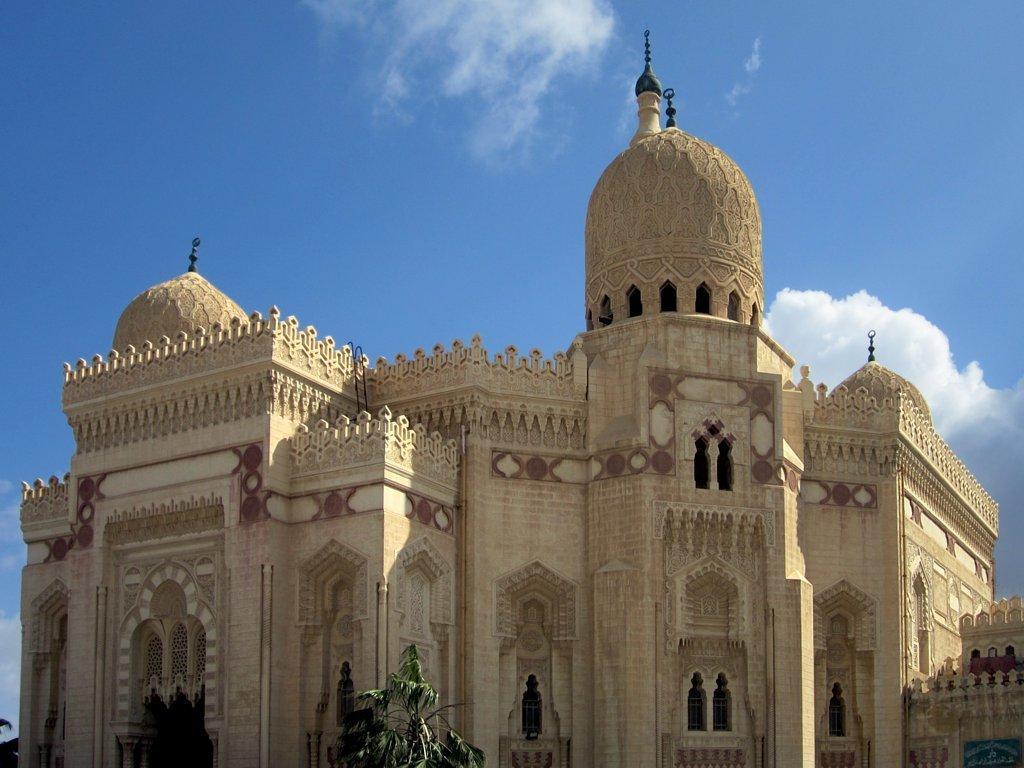How would you summarize this image in a sentence or two? This image consists of a building. At the top, there are clouds in the sky. At the bottom, we can see a tree. And we can see the windows in this image. 